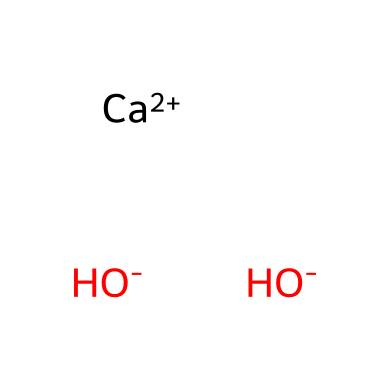What is the chemical name of this compound? The SMILES representation corresponds to calcium hydroxide. The presence of calcium (Ca) and hydroxide ions (OH-) indicates that it is composed of calcium and hydroxide, leading to the name calcium hydroxide.
Answer: calcium hydroxide How many hydroxide ions are present in this compound? The SMILES notation shows two hydroxide ions (OH-), which are represented by two instances of OH associated with the calcium ion.
Answer: two What type of compound is calcium hydroxide? Calcium hydroxide is classified as a base due to its hydroxide ions (OH-) which are characteristic of basic compounds that can accept protons in reactions.
Answer: base What is the total number of atoms in calcium hydroxide? The compound consists of one calcium atom (Ca) and two oxygen atoms (from two hydroxides), and two hydrogen atoms (from two hydroxides). Hence, the total is 1 + 2 (from hydroxides) + 2 (hydrogens) = 5.
Answer: five What is the primary role of calcium hydroxide in medieval whitewashing? Calcium hydroxide serves as a primary component in whitewashing, providing a basic reaction that bonds to surfaces and improves the aesthetics and protective qualities of the paint used in whitewashing.
Answer: protective coating What does the presence of hydroxide ions indicate about calcium hydroxide? The presence of hydroxide ions suggests that calcium hydroxide has the capability to cause a basic effect on surfaces, making them alkaline, which helps to deter fungal growth and degradation.
Answer: alkaline effect 